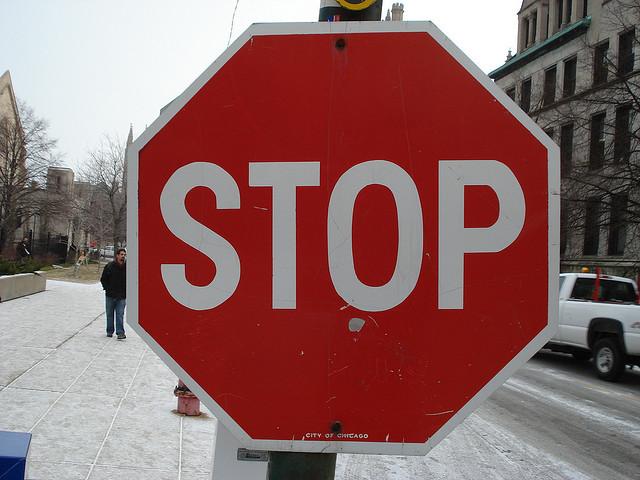What kind of sign is this?
Keep it brief. Stop. Is there a man or woman standing directly behind the stop sign?
Give a very brief answer. Man. Is there a cone in the truck?
Concise answer only. Yes. 